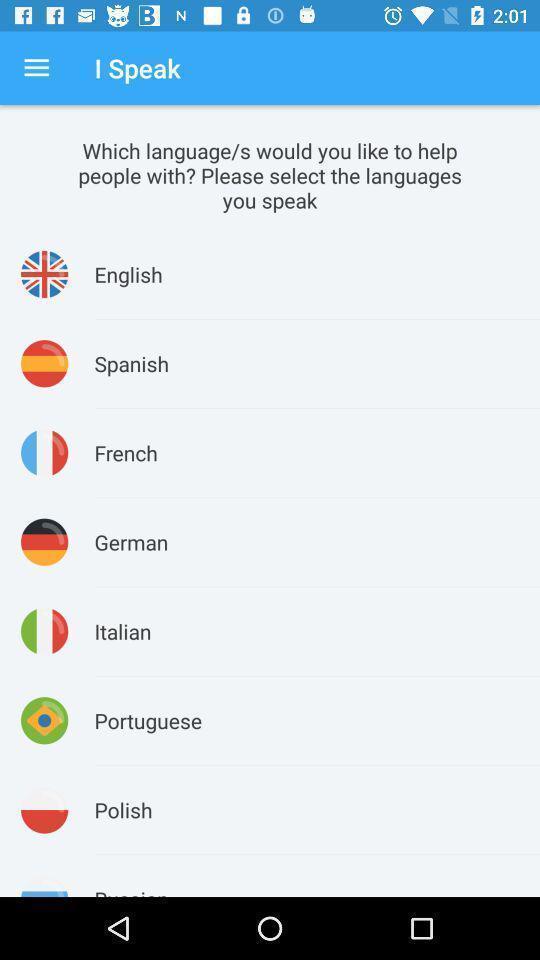Provide a textual representation of this image. Screen shows multiple languages options. 